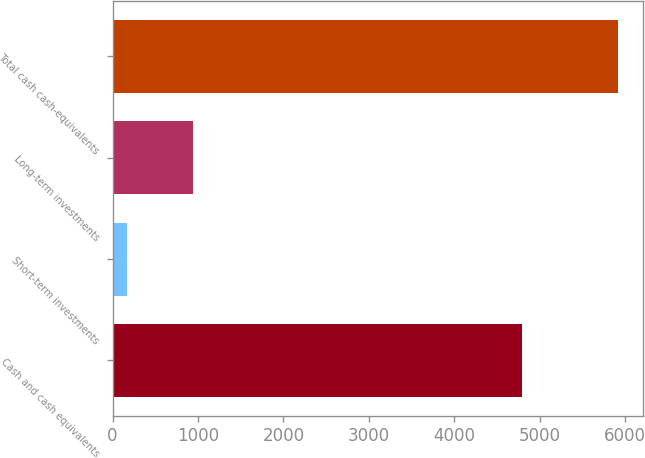<chart> <loc_0><loc_0><loc_500><loc_500><bar_chart><fcel>Cash and cash equivalents<fcel>Short-term investments<fcel>Long-term investments<fcel>Total cash cash-equivalents<nl><fcel>4797<fcel>168<fcel>946<fcel>5911<nl></chart> 